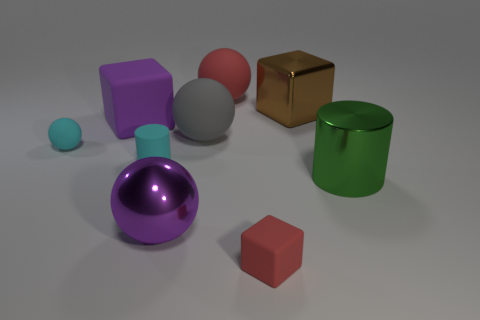Is the number of gray balls in front of the tiny cylinder greater than the number of purple things?
Offer a very short reply. No. What is the material of the brown object?
Your answer should be compact. Metal. What number of cyan things are the same size as the cyan matte cylinder?
Provide a short and direct response. 1. Are there an equal number of objects that are on the right side of the purple metal thing and big brown objects right of the tiny cylinder?
Give a very brief answer. No. Does the big brown object have the same material as the tiny cyan sphere?
Your answer should be compact. No. Are there any small matte things that are in front of the cyan rubber thing to the left of the cyan matte cylinder?
Provide a succinct answer. Yes. Are there any purple rubber objects of the same shape as the green object?
Ensure brevity in your answer.  No. Is the color of the matte cylinder the same as the tiny matte ball?
Offer a very short reply. Yes. The cylinder that is to the left of the cylinder right of the red sphere is made of what material?
Provide a succinct answer. Rubber. How big is the cyan matte sphere?
Provide a succinct answer. Small. 